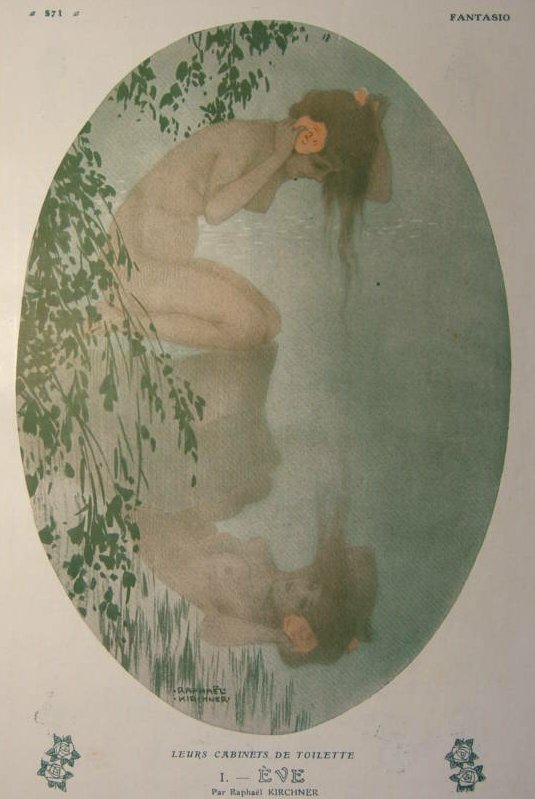What time period does this artwork most likely belong to? This artwork most likely belongs to the late 19th to early 20th century, a period marked by the prominence of the Art Nouveau movement. Art Nouveau, known for its organic forms, intricate patterns, and an emphasis on beauty and craftsmanship, flourished during this time. Can you tell me more about the artist Raphael Kirchner? Raphael Kirchner (1876–1917) was an Austrian artist and illustrator known for his contributions to the Art Nouveau movement. He was particularly famous for his elegant and sensuous depictions of women, often portrayed in serene and idyllic settings. Kirchner's works were published in numerous postcards, prints, and magazines, gaining widespread popularity across Europe and North America. His artistic style combined elements of fantasy, nature, and delicate beauty, making his pieces highly sought after during his time. Kirchner's legacy continues to influence contemporary art, particularly in the realm of illustration and design. 